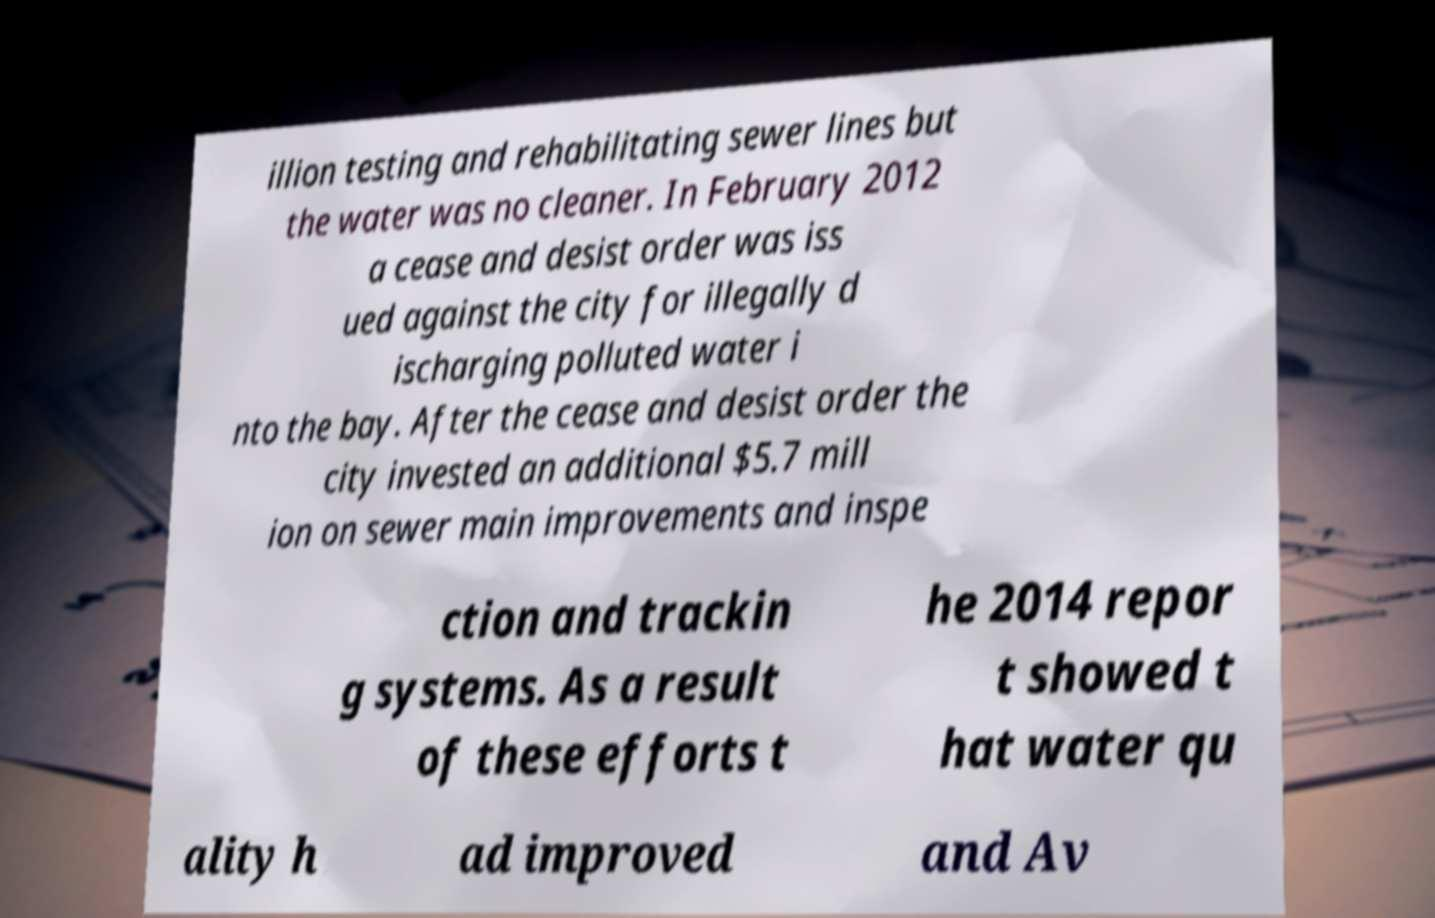Can you read and provide the text displayed in the image?This photo seems to have some interesting text. Can you extract and type it out for me? illion testing and rehabilitating sewer lines but the water was no cleaner. In February 2012 a cease and desist order was iss ued against the city for illegally d ischarging polluted water i nto the bay. After the cease and desist order the city invested an additional $5.7 mill ion on sewer main improvements and inspe ction and trackin g systems. As a result of these efforts t he 2014 repor t showed t hat water qu ality h ad improved and Av 